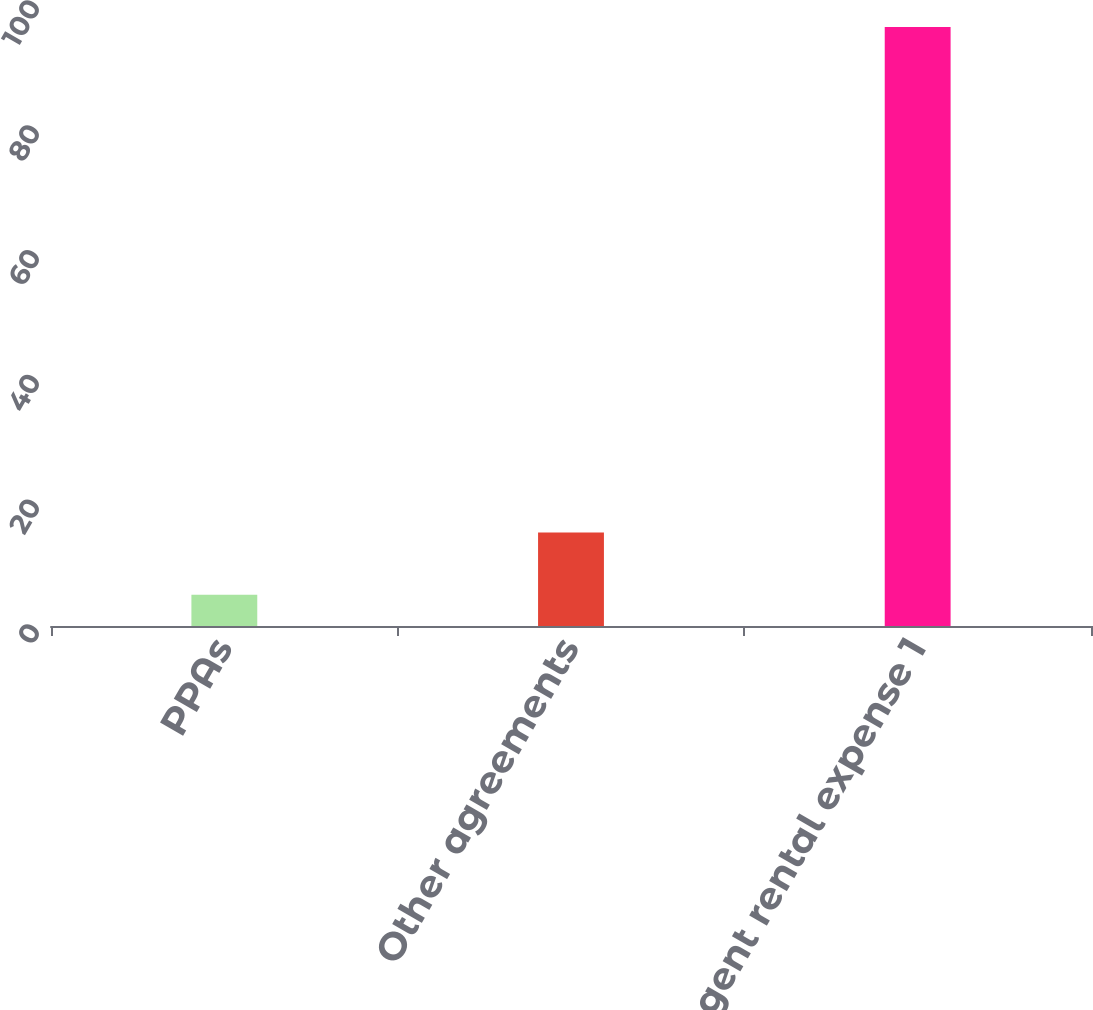<chart> <loc_0><loc_0><loc_500><loc_500><bar_chart><fcel>PPAs<fcel>Other agreements<fcel>Contingent rental expense 1<nl><fcel>5<fcel>15<fcel>96<nl></chart> 